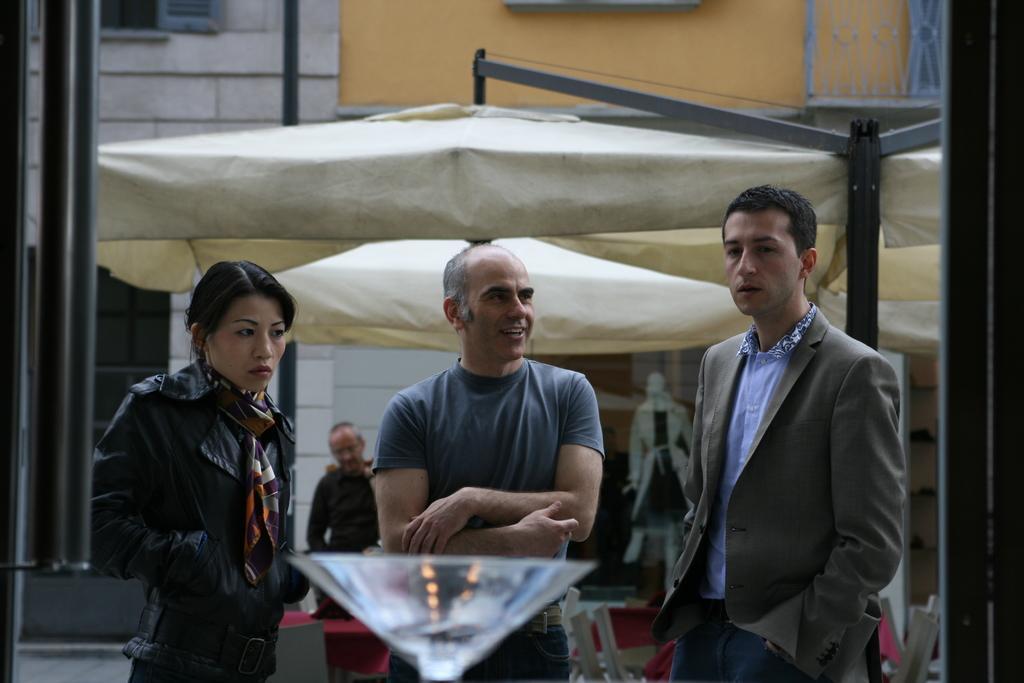Could you give a brief overview of what you see in this image? This picture shows few people standing and we see a woman and tent on the back and we see a building and a mannequin and couple of poles. 